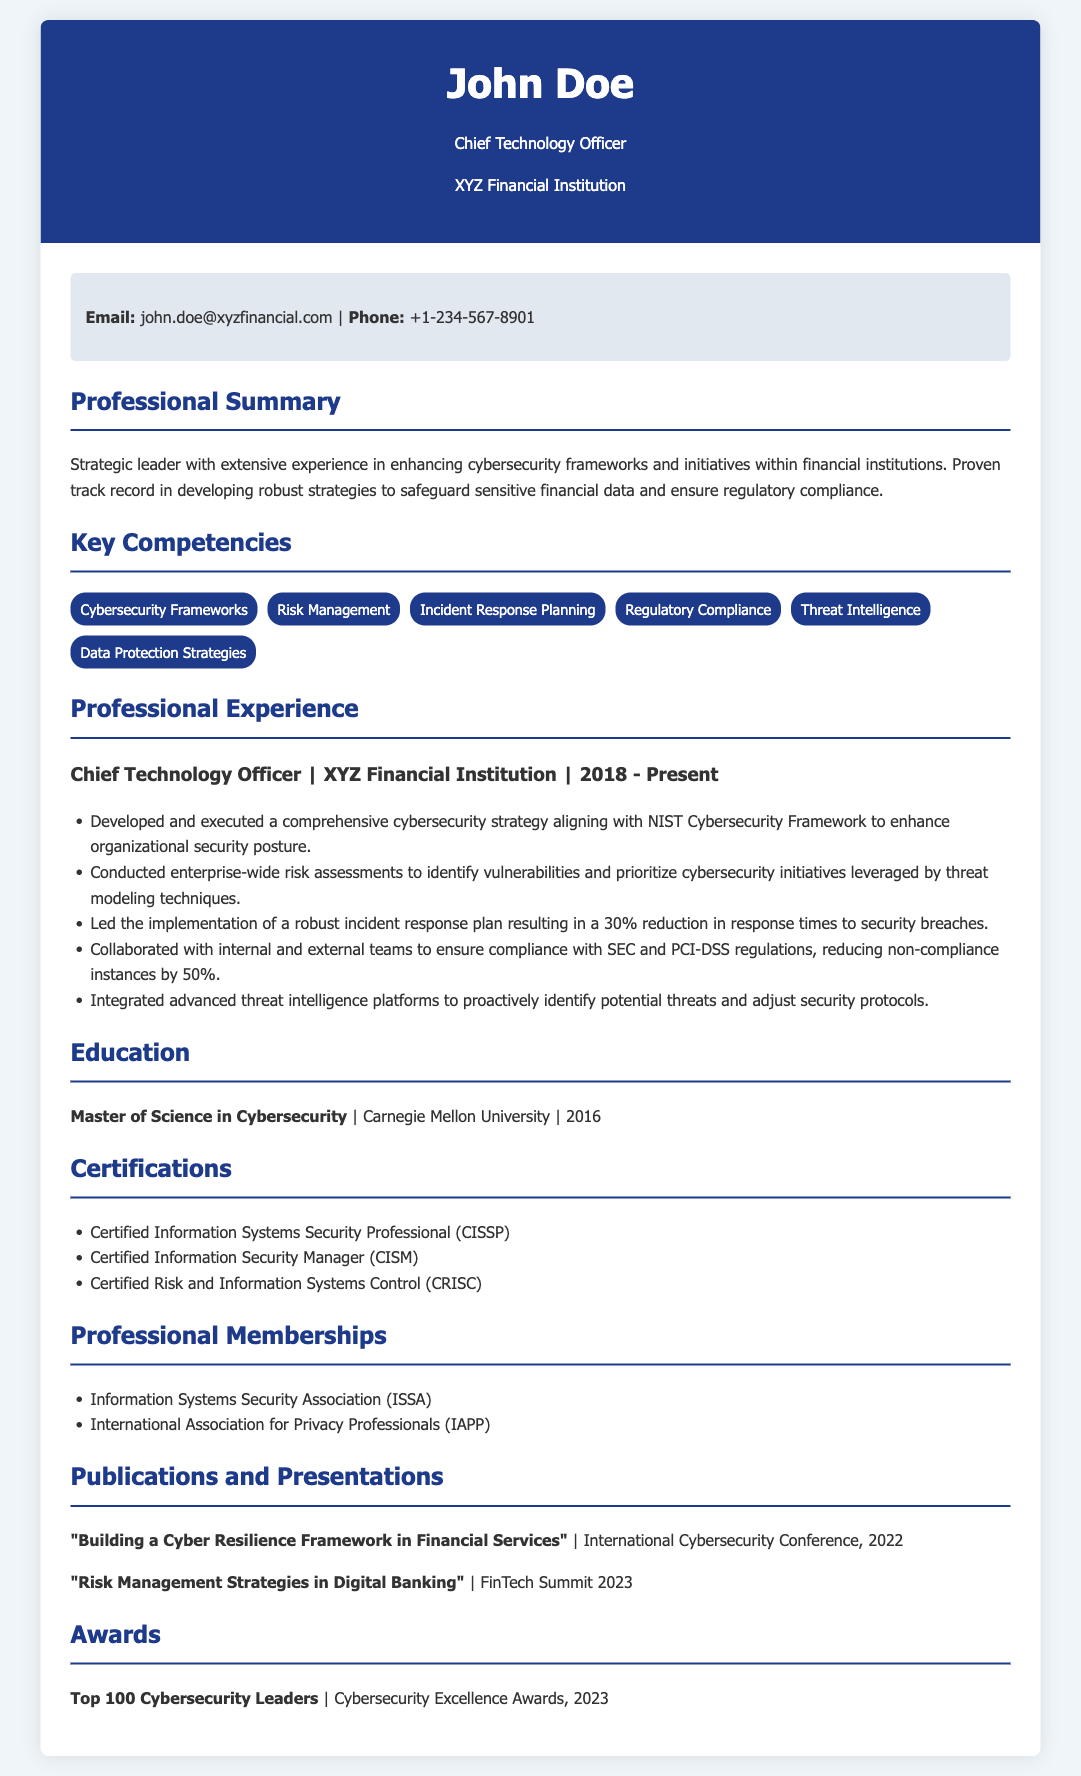what is the name of the Chief Technology Officer? The document lists the name of the Chief Technology Officer as John Doe.
Answer: John Doe which institution did John Doe obtain his Master's degree from? The curriculum vitae states that John Doe earned his Master's degree from Carnegie Mellon University.
Answer: Carnegie Mellon University how many years has John Doe worked at XYZ Financial Institution? The timeline indicates that John Doe has been at XYZ Financial Institution since 2018 and the current year is 2023, making it 5 years.
Answer: 5 years what percentage reduction in response times to security breaches was achieved? The document notes a 30% reduction in response times to security breaches due to the incident response plan.
Answer: 30% what is one of the key competencies listed for John Doe? The key competencies section lists several areas, including Cybersecurity Frameworks.
Answer: Cybersecurity Frameworks which certification is listed first in John Doe's certifications? The order of the listed certifications shows that Certified Information Systems Security Professional is the first.
Answer: Certified Information Systems Security Professional what award did John Doe receive in 2023? The CV states that John Doe was recognized as a Top 100 Cybersecurity Leader at the Cybersecurity Excellence Awards in 2023.
Answer: Top 100 Cybersecurity Leaders what framework was used to enhance the organization's cybersecurity posture? The document specifies that the NIST Cybersecurity Framework was used for this purpose.
Answer: NIST Cybersecurity Framework which professional membership is related to information security? The document lists the Information Systems Security Association as one of John Doe's memberships.
Answer: Information Systems Security Association 